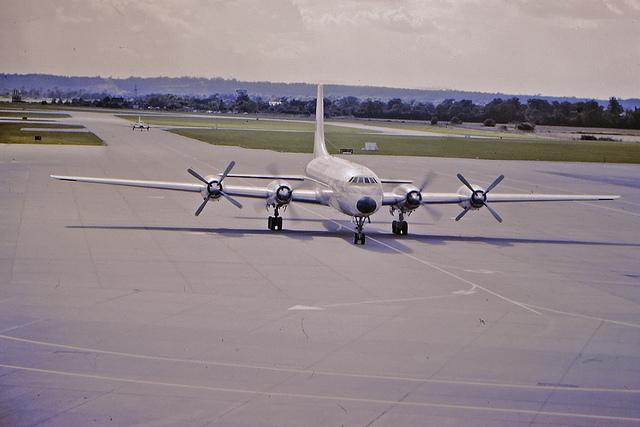Where is the vehicle located? runway 